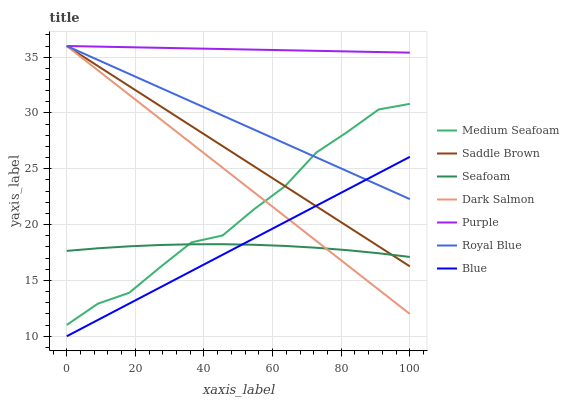Does Seafoam have the minimum area under the curve?
Answer yes or no. Yes. Does Purple have the maximum area under the curve?
Answer yes or no. Yes. Does Dark Salmon have the minimum area under the curve?
Answer yes or no. No. Does Dark Salmon have the maximum area under the curve?
Answer yes or no. No. Is Purple the smoothest?
Answer yes or no. Yes. Is Medium Seafoam the roughest?
Answer yes or no. Yes. Is Dark Salmon the smoothest?
Answer yes or no. No. Is Dark Salmon the roughest?
Answer yes or no. No. Does Blue have the lowest value?
Answer yes or no. Yes. Does Dark Salmon have the lowest value?
Answer yes or no. No. Does Saddle Brown have the highest value?
Answer yes or no. Yes. Does Seafoam have the highest value?
Answer yes or no. No. Is Medium Seafoam less than Purple?
Answer yes or no. Yes. Is Purple greater than Seafoam?
Answer yes or no. Yes. Does Medium Seafoam intersect Seafoam?
Answer yes or no. Yes. Is Medium Seafoam less than Seafoam?
Answer yes or no. No. Is Medium Seafoam greater than Seafoam?
Answer yes or no. No. Does Medium Seafoam intersect Purple?
Answer yes or no. No. 